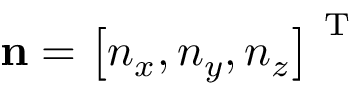<formula> <loc_0><loc_0><loc_500><loc_500>n = \left [ n _ { x } , n _ { y } , n _ { z } \right ] ^ { T }</formula> 